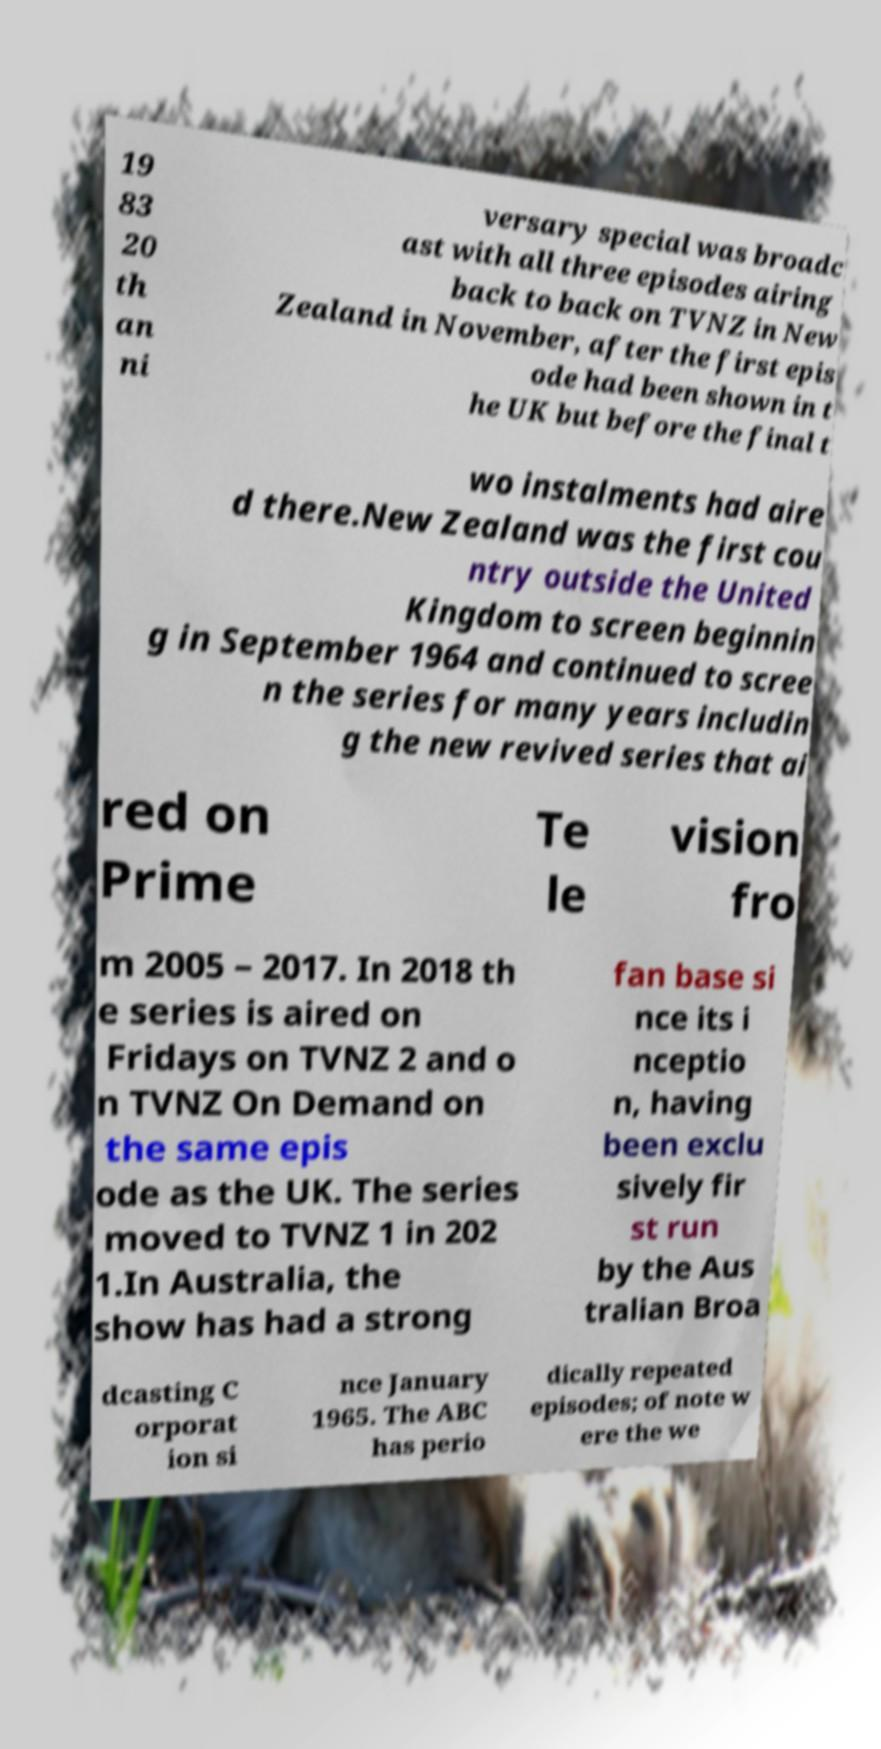Please read and relay the text visible in this image. What does it say? 19 83 20 th an ni versary special was broadc ast with all three episodes airing back to back on TVNZ in New Zealand in November, after the first epis ode had been shown in t he UK but before the final t wo instalments had aire d there.New Zealand was the first cou ntry outside the United Kingdom to screen beginnin g in September 1964 and continued to scree n the series for many years includin g the new revived series that ai red on Prime Te le vision fro m 2005 – 2017. In 2018 th e series is aired on Fridays on TVNZ 2 and o n TVNZ On Demand on the same epis ode as the UK. The series moved to TVNZ 1 in 202 1.In Australia, the show has had a strong fan base si nce its i nceptio n, having been exclu sively fir st run by the Aus tralian Broa dcasting C orporat ion si nce January 1965. The ABC has perio dically repeated episodes; of note w ere the we 